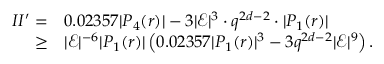<formula> <loc_0><loc_0><loc_500><loc_500>\begin{array} { r l } { I I ^ { \prime } = } & { 0 . 0 2 3 5 7 | P _ { 4 } ( r ) | - 3 | \mathcal { E } | ^ { 3 } \cdot q ^ { 2 d - 2 } \cdot | P _ { 1 } ( r ) | } \\ { \geq } & { | \mathcal { E } | ^ { - 6 } | P _ { 1 } ( r ) | \left ( 0 . 0 2 3 5 7 | P _ { 1 } ( r ) | ^ { 3 } - 3 q ^ { 2 d - 2 } | \mathcal { E } | ^ { 9 } \right ) . } \end{array}</formula> 